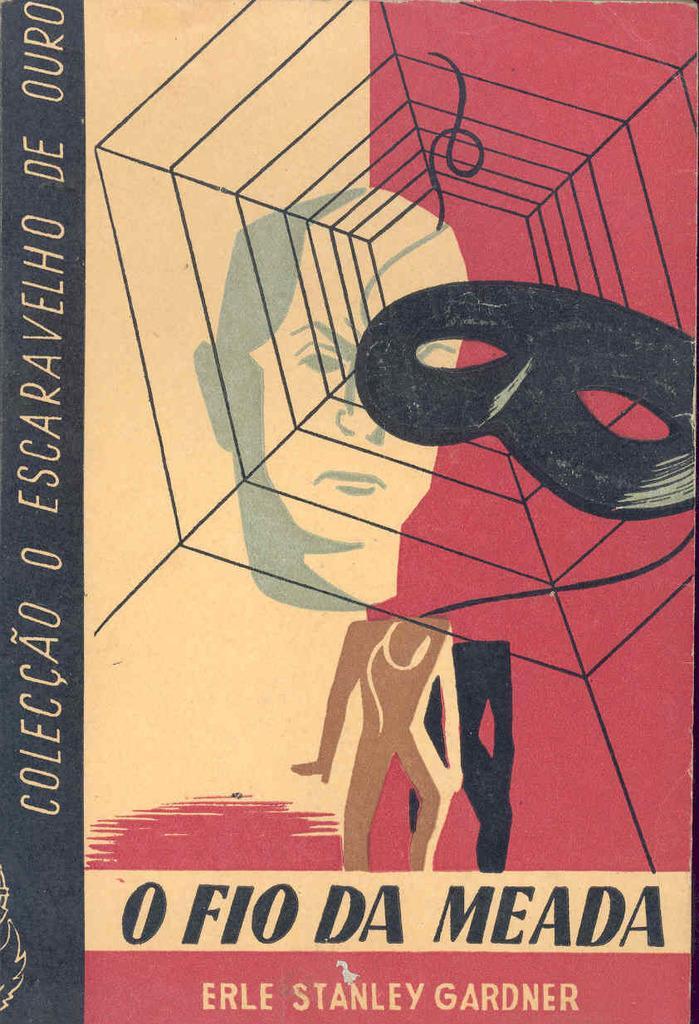Please provide a concise description of this image. In this image, we can see a magazine. Here we can see few figures and text. 